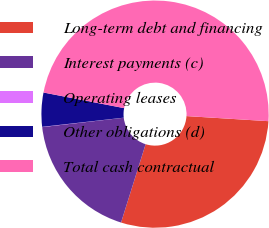<chart> <loc_0><loc_0><loc_500><loc_500><pie_chart><fcel>Long-term debt and financing<fcel>Interest payments (c)<fcel>Operating leases<fcel>Other obligations (d)<fcel>Total cash contractual<nl><fcel>28.85%<fcel>18.34%<fcel>0.04%<fcel>4.83%<fcel>47.94%<nl></chart> 